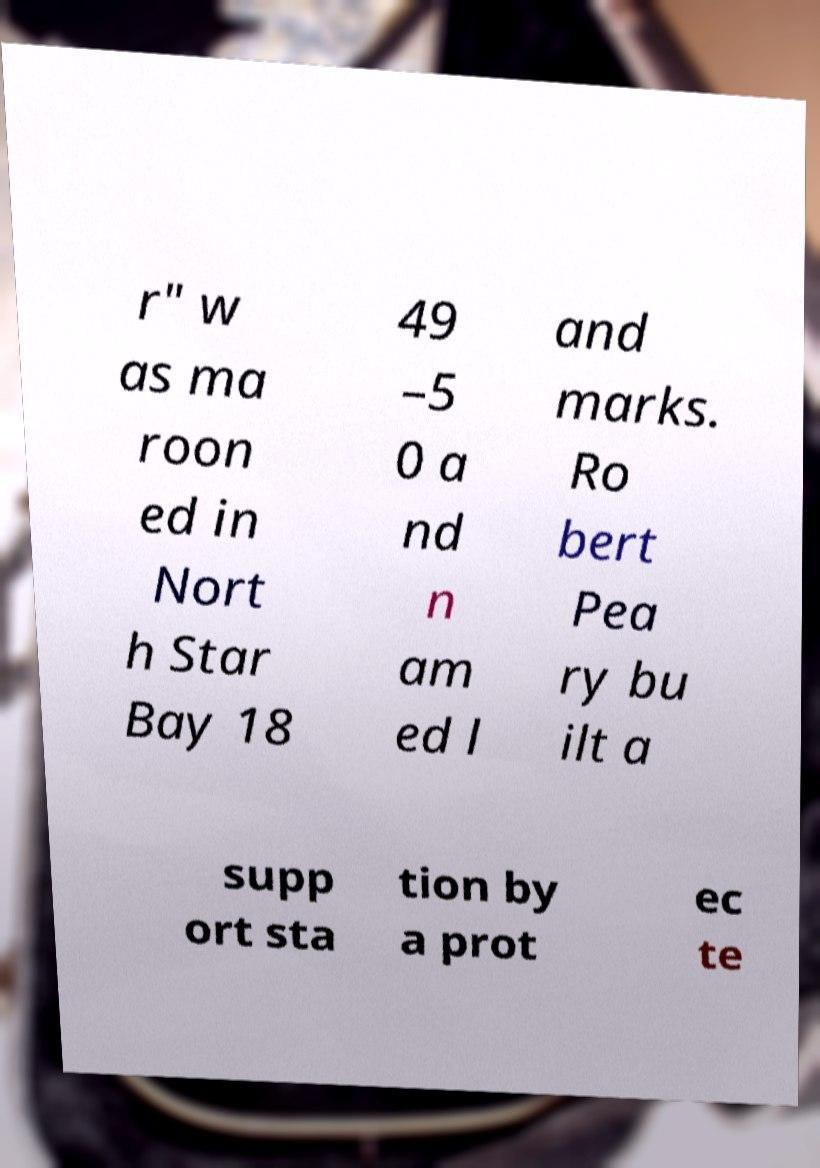Could you assist in decoding the text presented in this image and type it out clearly? r" w as ma roon ed in Nort h Star Bay 18 49 –5 0 a nd n am ed l and marks. Ro bert Pea ry bu ilt a supp ort sta tion by a prot ec te 